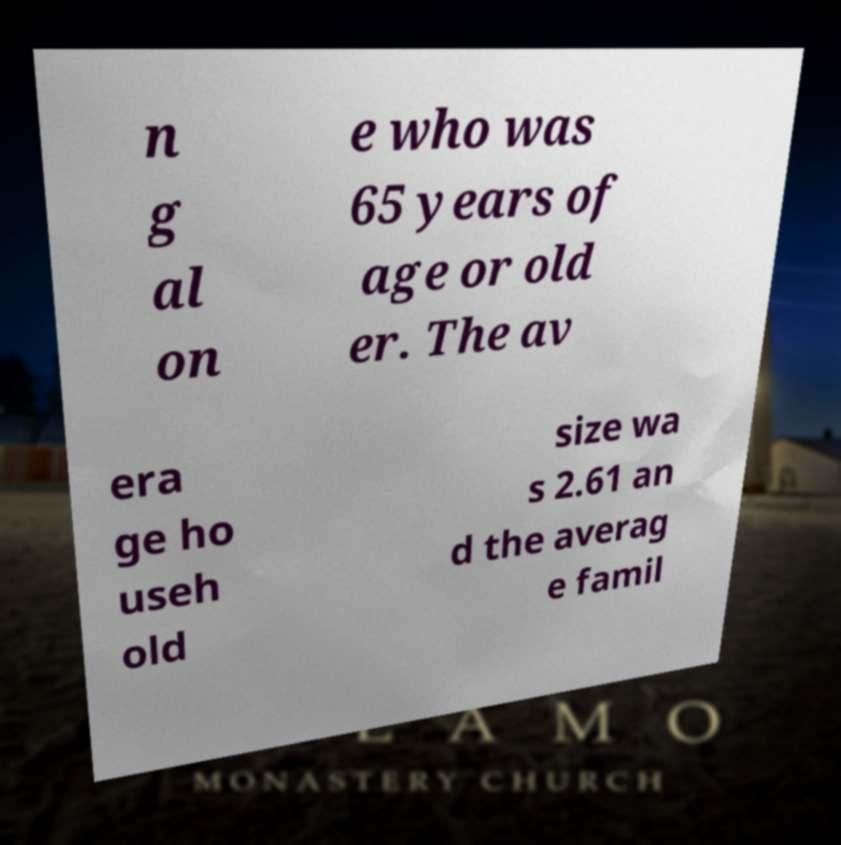For documentation purposes, I need the text within this image transcribed. Could you provide that? n g al on e who was 65 years of age or old er. The av era ge ho useh old size wa s 2.61 an d the averag e famil 